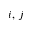<formula> <loc_0><loc_0><loc_500><loc_500>i , \, j</formula> 